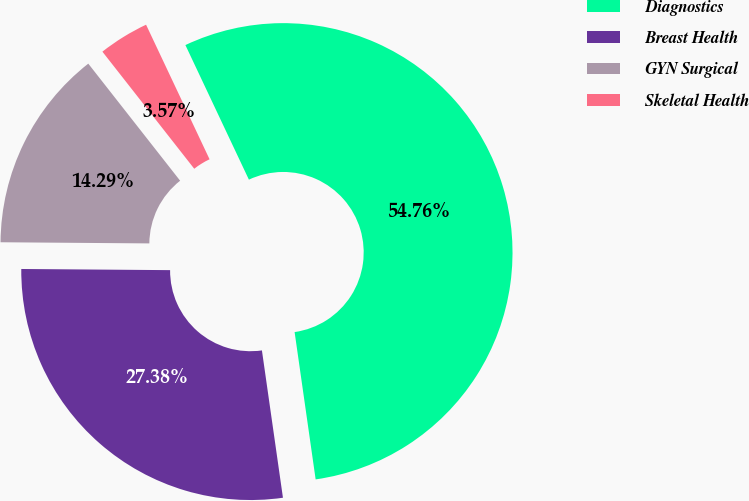Convert chart. <chart><loc_0><loc_0><loc_500><loc_500><pie_chart><fcel>Diagnostics<fcel>Breast Health<fcel>GYN Surgical<fcel>Skeletal Health<nl><fcel>54.76%<fcel>27.38%<fcel>14.29%<fcel>3.57%<nl></chart> 